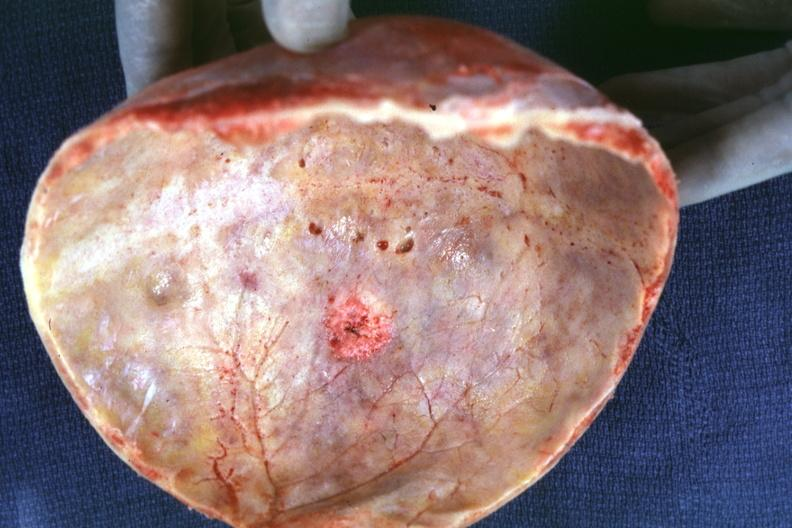how is skull cap with obvious metastatic lesion seen on inner table prostate?
Answer the question using a single word or phrase. Primary 